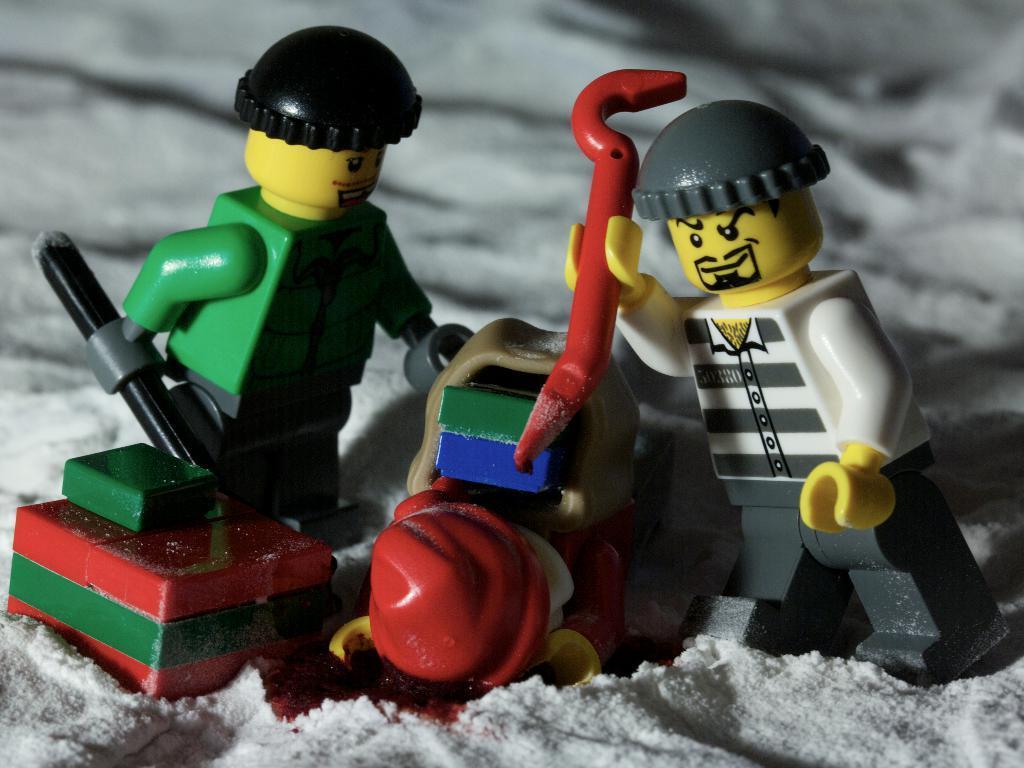Describe this image in one or two sentences. In the image we can see there are toys standing on the ground. The ground is covered with snow and toys are holding rods in their hand. 